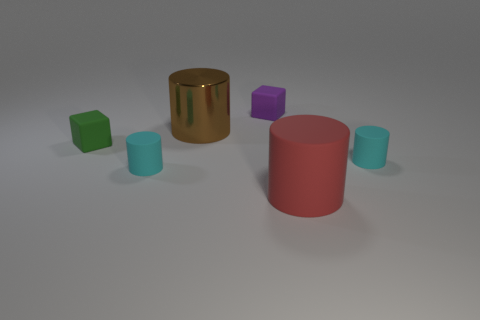Add 2 big red cylinders. How many objects exist? 8 Subtract all cylinders. How many objects are left? 2 Add 3 green spheres. How many green spheres exist? 3 Subtract 0 purple cylinders. How many objects are left? 6 Subtract all cyan things. Subtract all green objects. How many objects are left? 3 Add 1 purple cubes. How many purple cubes are left? 2 